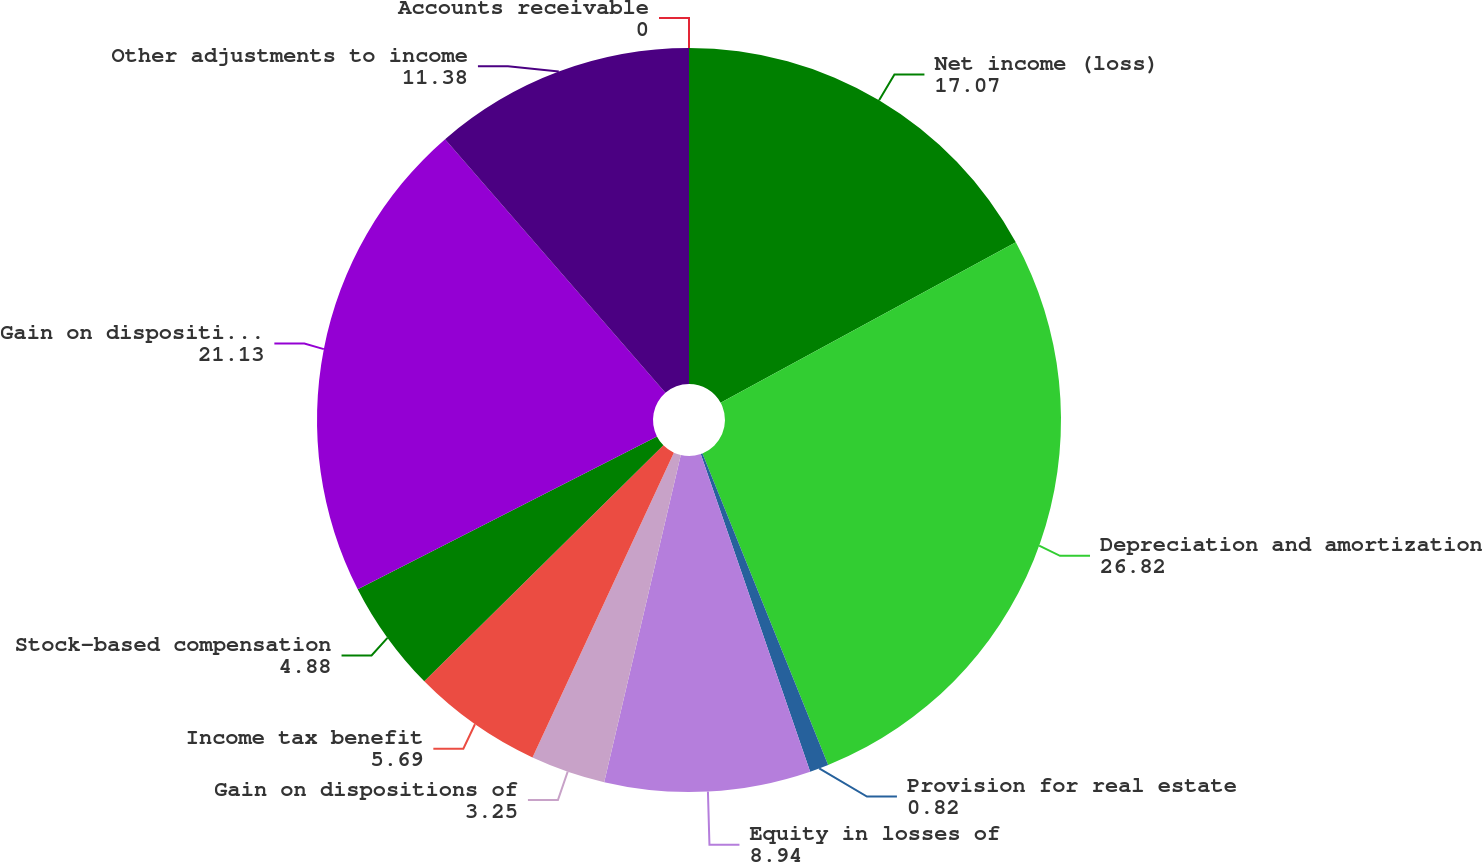Convert chart to OTSL. <chart><loc_0><loc_0><loc_500><loc_500><pie_chart><fcel>Net income (loss)<fcel>Depreciation and amortization<fcel>Provision for real estate<fcel>Equity in losses of<fcel>Gain on dispositions of<fcel>Income tax benefit<fcel>Stock-based compensation<fcel>Gain on disposition of real<fcel>Other adjustments to income<fcel>Accounts receivable<nl><fcel>17.07%<fcel>26.82%<fcel>0.82%<fcel>8.94%<fcel>3.25%<fcel>5.69%<fcel>4.88%<fcel>21.13%<fcel>11.38%<fcel>0.0%<nl></chart> 